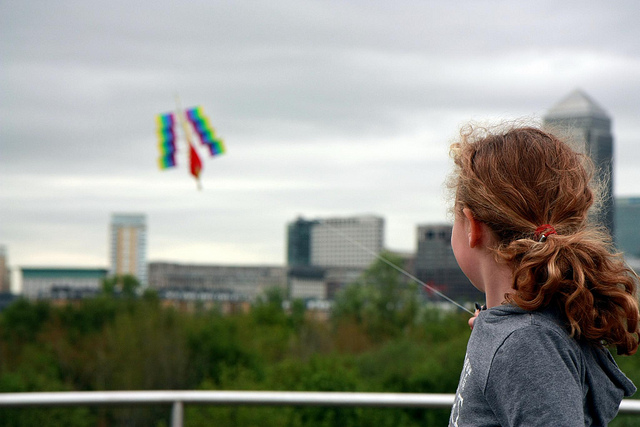<image>What is the message on the shirt referencing? The message on the shirt is unknown or unclear. What is the message on the shirt referencing? It is unclear what the message on the shirt is referencing. 